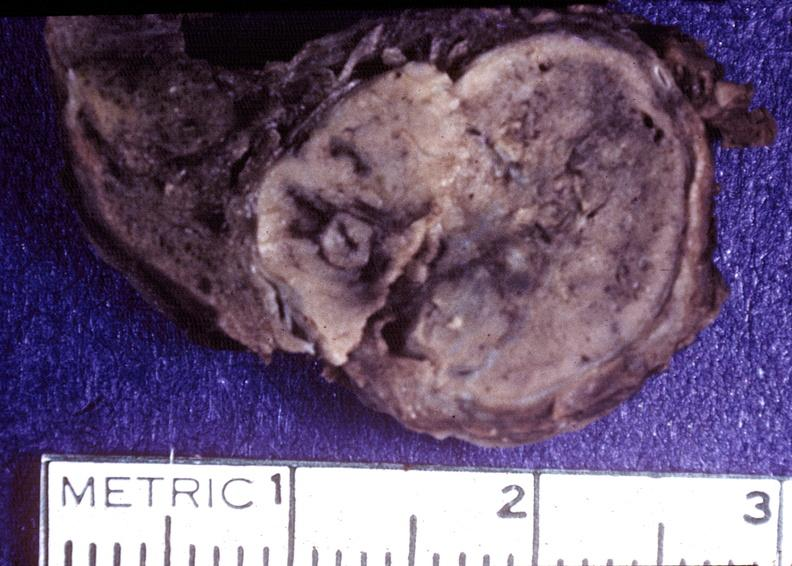does acute peritonitis show thyroid, hurthle cell adenoma?
Answer the question using a single word or phrase. No 